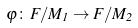<formula> <loc_0><loc_0><loc_500><loc_500>\varphi \colon F / M _ { 1 } \rightarrow F / M _ { 2 }</formula> 